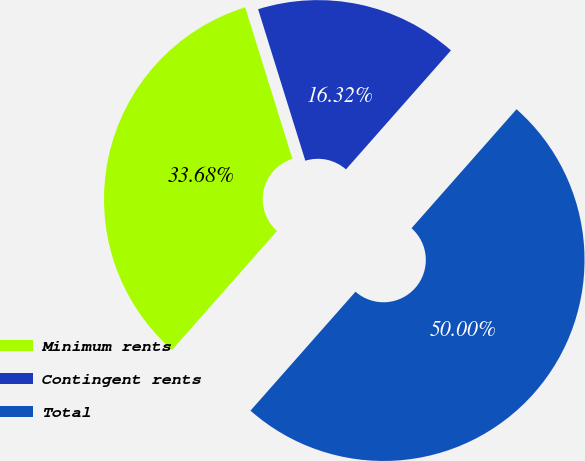<chart> <loc_0><loc_0><loc_500><loc_500><pie_chart><fcel>Minimum rents<fcel>Contingent rents<fcel>Total<nl><fcel>33.68%<fcel>16.32%<fcel>50.0%<nl></chart> 